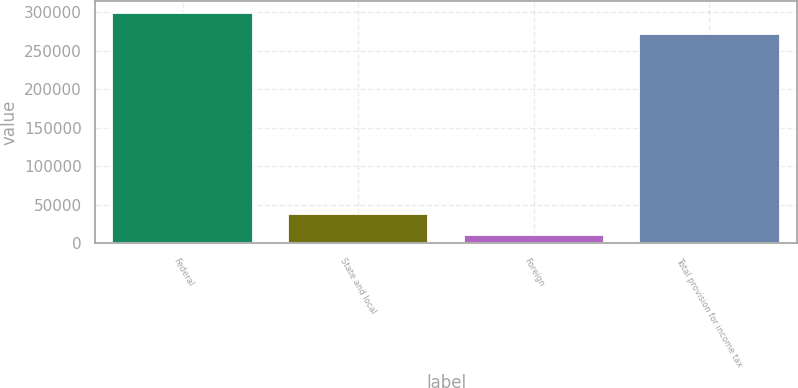Convert chart to OTSL. <chart><loc_0><loc_0><loc_500><loc_500><bar_chart><fcel>Federal<fcel>State and local<fcel>Foreign<fcel>Total provision for income tax<nl><fcel>298964<fcel>38311<fcel>10640<fcel>271293<nl></chart> 